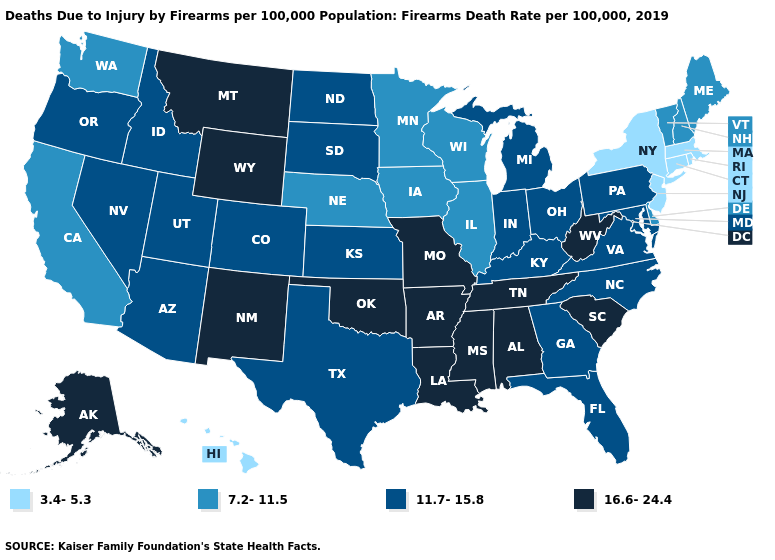Does New Jersey have the lowest value in the USA?
Be succinct. Yes. Among the states that border North Dakota , does Minnesota have the lowest value?
Answer briefly. Yes. Which states have the lowest value in the MidWest?
Quick response, please. Illinois, Iowa, Minnesota, Nebraska, Wisconsin. Does Idaho have a lower value than California?
Write a very short answer. No. What is the lowest value in the Northeast?
Quick response, please. 3.4-5.3. What is the value of Maryland?
Short answer required. 11.7-15.8. Which states have the highest value in the USA?
Concise answer only. Alabama, Alaska, Arkansas, Louisiana, Mississippi, Missouri, Montana, New Mexico, Oklahoma, South Carolina, Tennessee, West Virginia, Wyoming. Name the states that have a value in the range 16.6-24.4?
Answer briefly. Alabama, Alaska, Arkansas, Louisiana, Mississippi, Missouri, Montana, New Mexico, Oklahoma, South Carolina, Tennessee, West Virginia, Wyoming. Among the states that border Maryland , which have the highest value?
Answer briefly. West Virginia. Among the states that border Connecticut , which have the lowest value?
Be succinct. Massachusetts, New York, Rhode Island. Name the states that have a value in the range 7.2-11.5?
Write a very short answer. California, Delaware, Illinois, Iowa, Maine, Minnesota, Nebraska, New Hampshire, Vermont, Washington, Wisconsin. Does Missouri have a higher value than New Hampshire?
Give a very brief answer. Yes. Among the states that border North Dakota , which have the lowest value?
Be succinct. Minnesota. Among the states that border Arizona , which have the lowest value?
Quick response, please. California. What is the value of Iowa?
Be succinct. 7.2-11.5. 